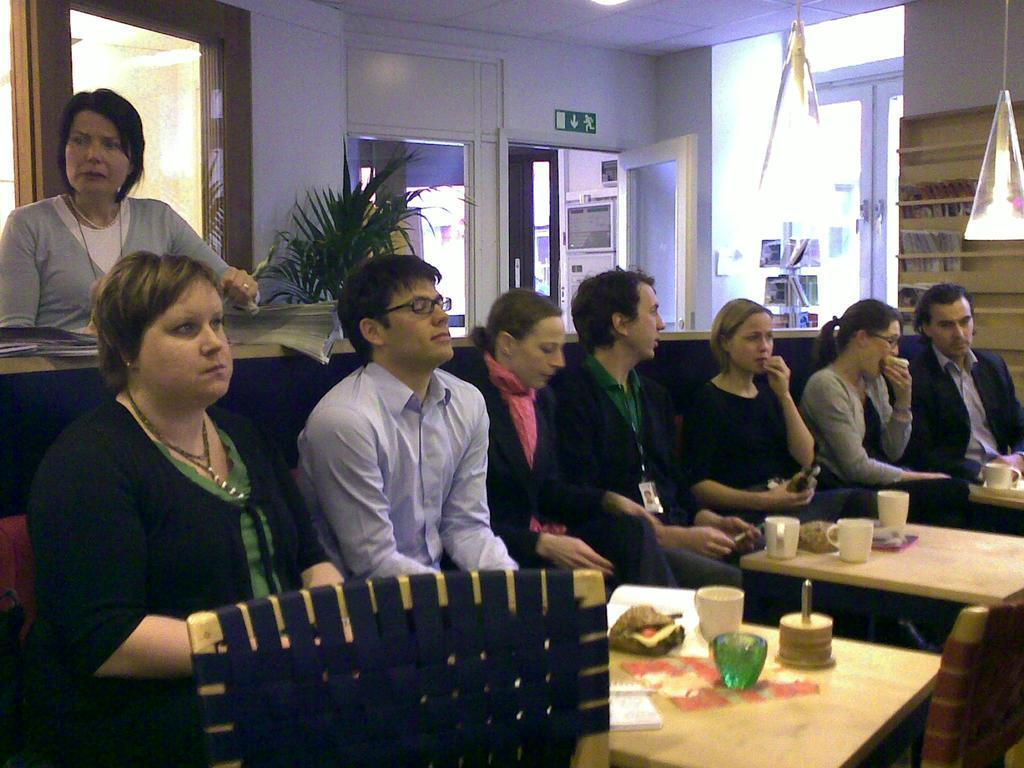Can you describe this image briefly? In this picture, we see four women and three men are sitting on the chairs. In front of them, we see the tables on which glasses, cups, plate containing food item and papers are placed. Behind them, we see a woman is standing. Beside her, we see the plant pot. Behind her, we see the glass windows. Beside that, we see a glass door and a wall. On the right side, we see a board and windows. We even see a flag. 